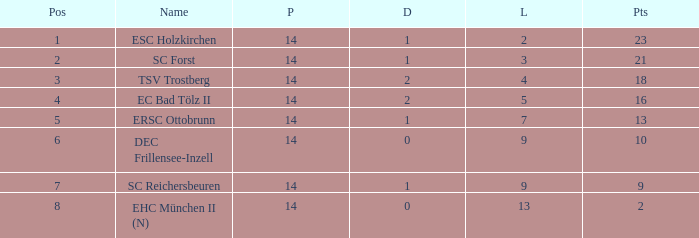How much Drawn has a Lost of 2, and Played smaller than 14? None. 